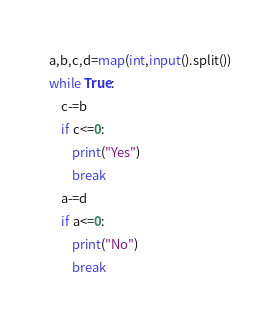<code> <loc_0><loc_0><loc_500><loc_500><_Python_>a,b,c,d=map(int,input().split())
while True:
    c-=b
    if c<=0:
        print("Yes")
        break
    a-=d
    if a<=0:
        print("No")
        break</code> 